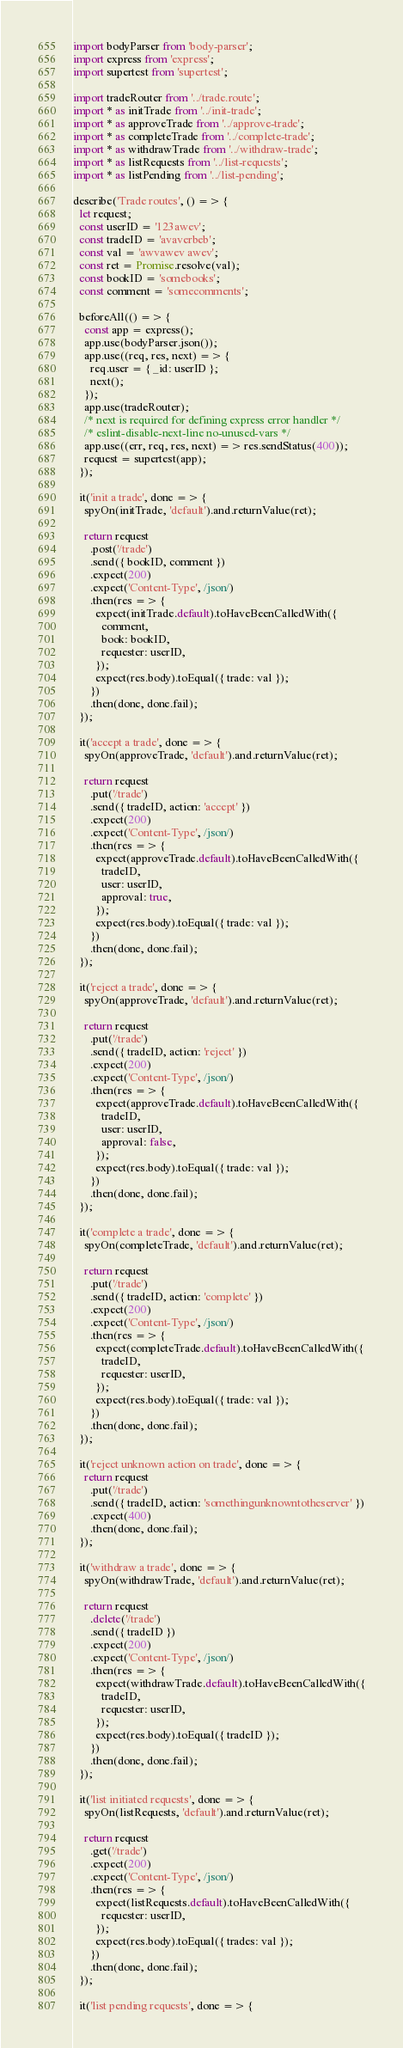<code> <loc_0><loc_0><loc_500><loc_500><_JavaScript_>import bodyParser from 'body-parser';
import express from 'express';
import supertest from 'supertest';

import tradeRouter from '../trade.route';
import * as initTrade from '../init-trade';
import * as approveTrade from '../approve-trade';
import * as completeTrade from '../complete-trade';
import * as withdrawTrade from '../withdraw-trade';
import * as listRequests from '../list-requests';
import * as listPending from '../list-pending';

describe('Trade routes', () => {
  let request;
  const userID = '123awev';
  const tradeID = 'avaverbeb';
  const val = 'awvawev awev';
  const ret = Promise.resolve(val);
  const bookID = 'somebooks';
  const comment = 'somecomments';

  beforeAll(() => {
    const app = express();
    app.use(bodyParser.json());
    app.use((req, res, next) => {
      req.user = { _id: userID };
      next();
    });
    app.use(tradeRouter);
    /* next is required for defining express error handler */
    /* eslint-disable-next-line no-unused-vars */
    app.use((err, req, res, next) => res.sendStatus(400));
    request = supertest(app);
  });

  it('init a trade', done => {
    spyOn(initTrade, 'default').and.returnValue(ret);

    return request
      .post('/trade')
      .send({ bookID, comment })
      .expect(200)
      .expect('Content-Type', /json/)
      .then(res => {
        expect(initTrade.default).toHaveBeenCalledWith({
          comment,
          book: bookID,
          requester: userID,
        });
        expect(res.body).toEqual({ trade: val });
      })
      .then(done, done.fail);
  });

  it('accept a trade', done => {
    spyOn(approveTrade, 'default').and.returnValue(ret);

    return request
      .put('/trade')
      .send({ tradeID, action: 'accept' })
      .expect(200)
      .expect('Content-Type', /json/)
      .then(res => {
        expect(approveTrade.default).toHaveBeenCalledWith({
          tradeID,
          user: userID,
          approval: true,
        });
        expect(res.body).toEqual({ trade: val });
      })
      .then(done, done.fail);
  });

  it('reject a trade', done => {
    spyOn(approveTrade, 'default').and.returnValue(ret);

    return request
      .put('/trade')
      .send({ tradeID, action: 'reject' })
      .expect(200)
      .expect('Content-Type', /json/)
      .then(res => {
        expect(approveTrade.default).toHaveBeenCalledWith({
          tradeID,
          user: userID,
          approval: false,
        });
        expect(res.body).toEqual({ trade: val });
      })
      .then(done, done.fail);
  });

  it('complete a trade', done => {
    spyOn(completeTrade, 'default').and.returnValue(ret);

    return request
      .put('/trade')
      .send({ tradeID, action: 'complete' })
      .expect(200)
      .expect('Content-Type', /json/)
      .then(res => {
        expect(completeTrade.default).toHaveBeenCalledWith({
          tradeID,
          requester: userID,
        });
        expect(res.body).toEqual({ trade: val });
      })
      .then(done, done.fail);
  });

  it('reject unknown action on trade', done => {
    return request
      .put('/trade')
      .send({ tradeID, action: 'somethingunknowntotheserver' })
      .expect(400)
      .then(done, done.fail);
  });

  it('withdraw a trade', done => {
    spyOn(withdrawTrade, 'default').and.returnValue(ret);

    return request
      .delete('/trade')
      .send({ tradeID })
      .expect(200)
      .expect('Content-Type', /json/)
      .then(res => {
        expect(withdrawTrade.default).toHaveBeenCalledWith({
          tradeID,
          requester: userID,
        });
        expect(res.body).toEqual({ tradeID });
      })
      .then(done, done.fail);
  });

  it('list initiated requests', done => {
    spyOn(listRequests, 'default').and.returnValue(ret);

    return request
      .get('/trade')
      .expect(200)
      .expect('Content-Type', /json/)
      .then(res => {
        expect(listRequests.default).toHaveBeenCalledWith({
          requester: userID,
        });
        expect(res.body).toEqual({ trades: val });
      })
      .then(done, done.fail);
  });

  it('list pending requests', done => {</code> 